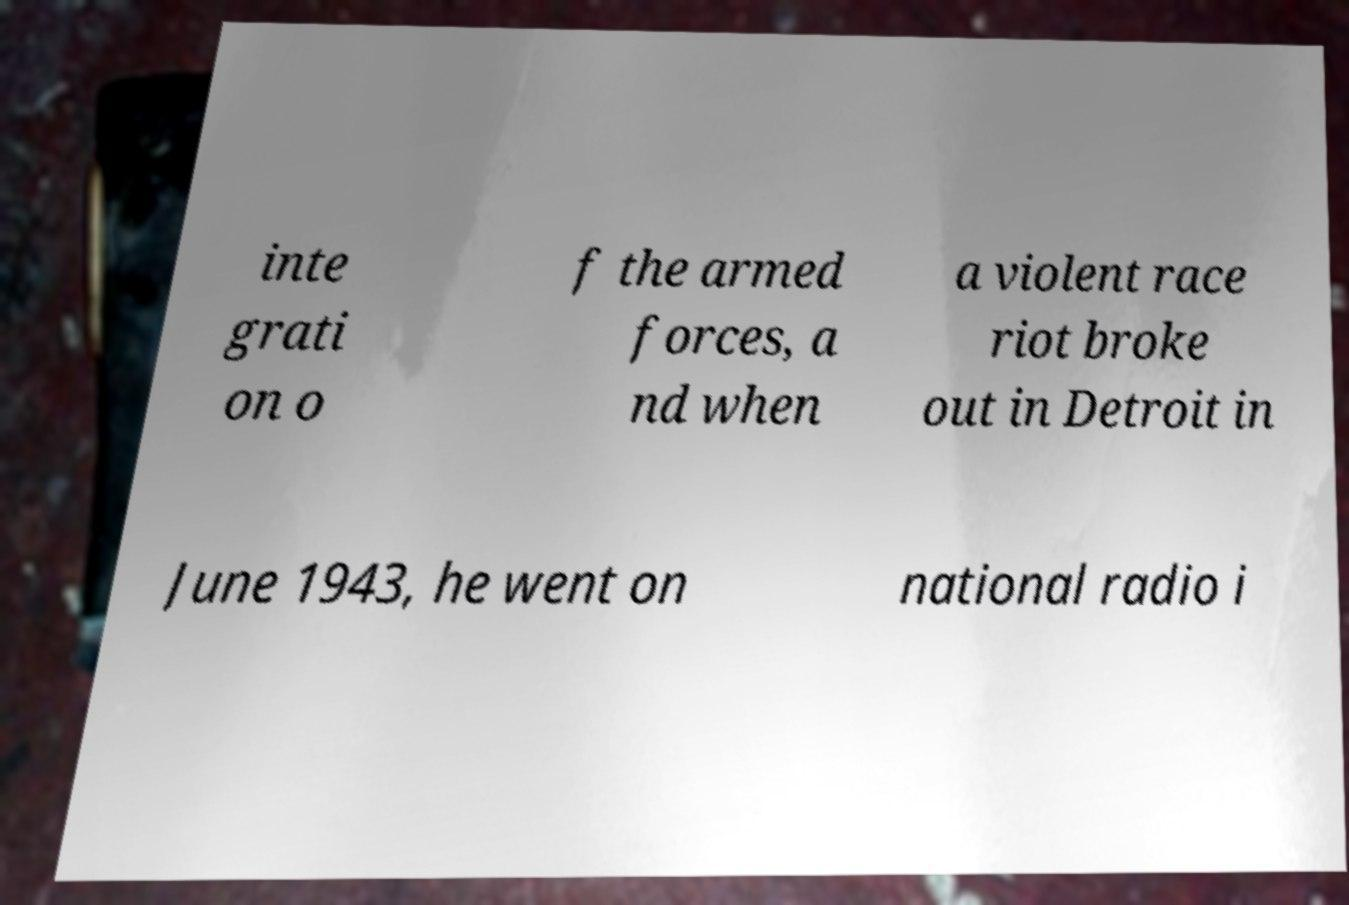Could you extract and type out the text from this image? inte grati on o f the armed forces, a nd when a violent race riot broke out in Detroit in June 1943, he went on national radio i 